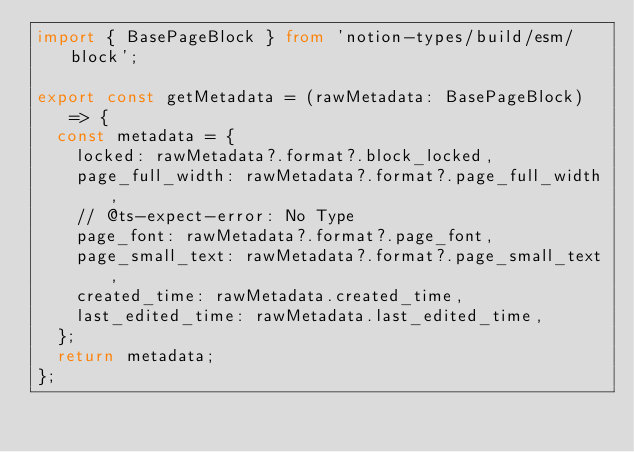Convert code to text. <code><loc_0><loc_0><loc_500><loc_500><_TypeScript_>import { BasePageBlock } from 'notion-types/build/esm/block';

export const getMetadata = (rawMetadata: BasePageBlock) => {
  const metadata = {
    locked: rawMetadata?.format?.block_locked,
    page_full_width: rawMetadata?.format?.page_full_width,
    // @ts-expect-error: No Type
    page_font: rawMetadata?.format?.page_font,
    page_small_text: rawMetadata?.format?.page_small_text,
    created_time: rawMetadata.created_time,
    last_edited_time: rawMetadata.last_edited_time,
  };
  return metadata;
};
</code> 